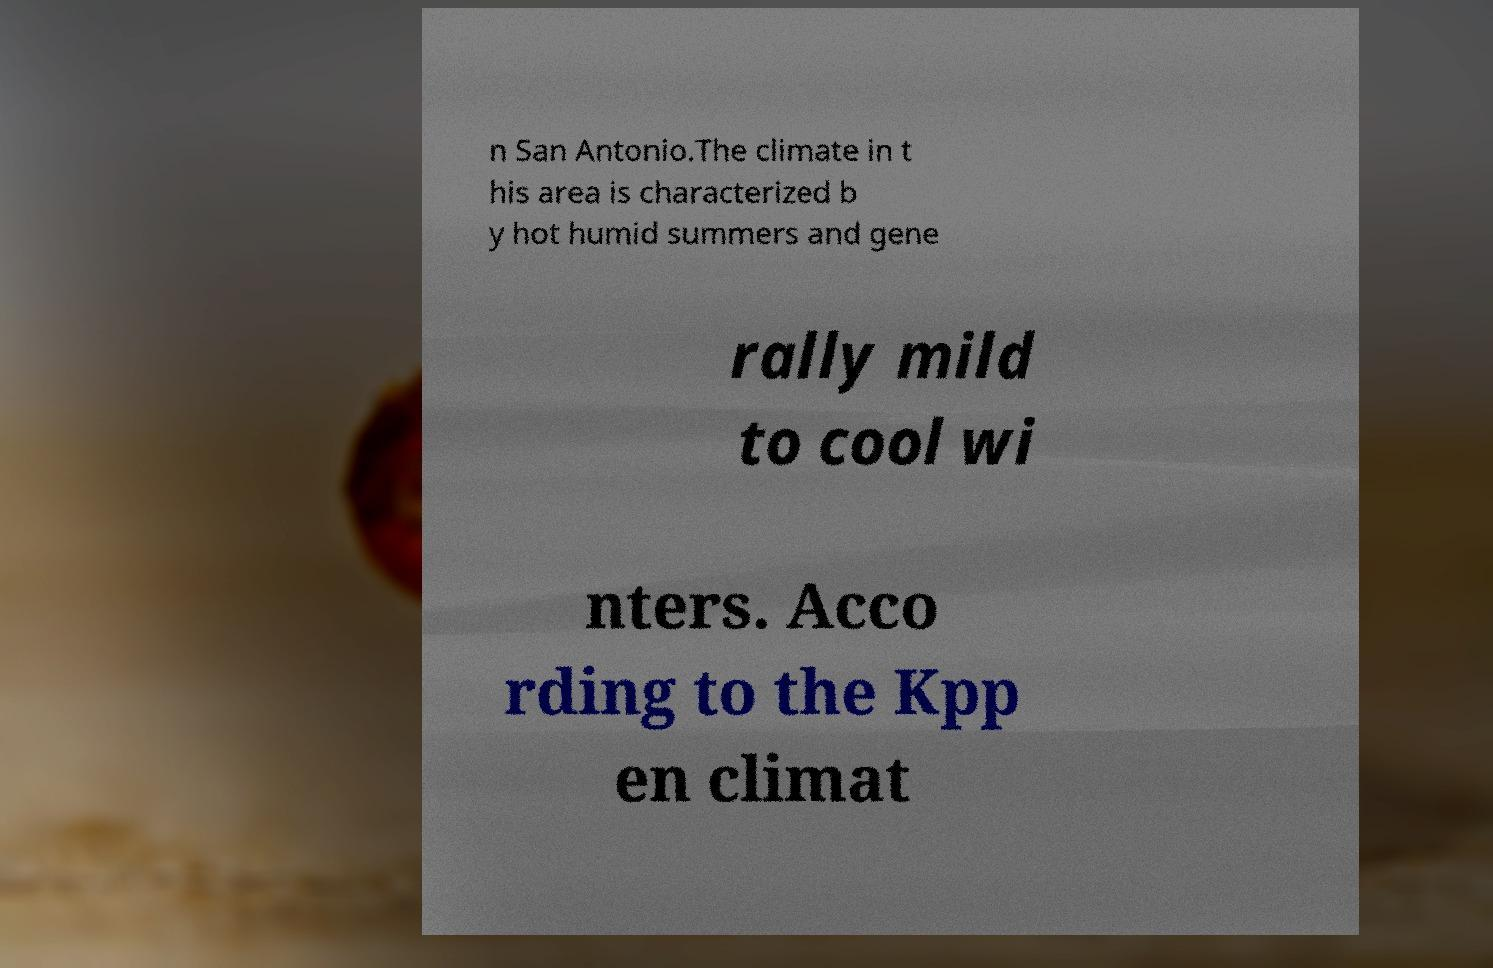Please identify and transcribe the text found in this image. n San Antonio.The climate in t his area is characterized b y hot humid summers and gene rally mild to cool wi nters. Acco rding to the Kpp en climat 